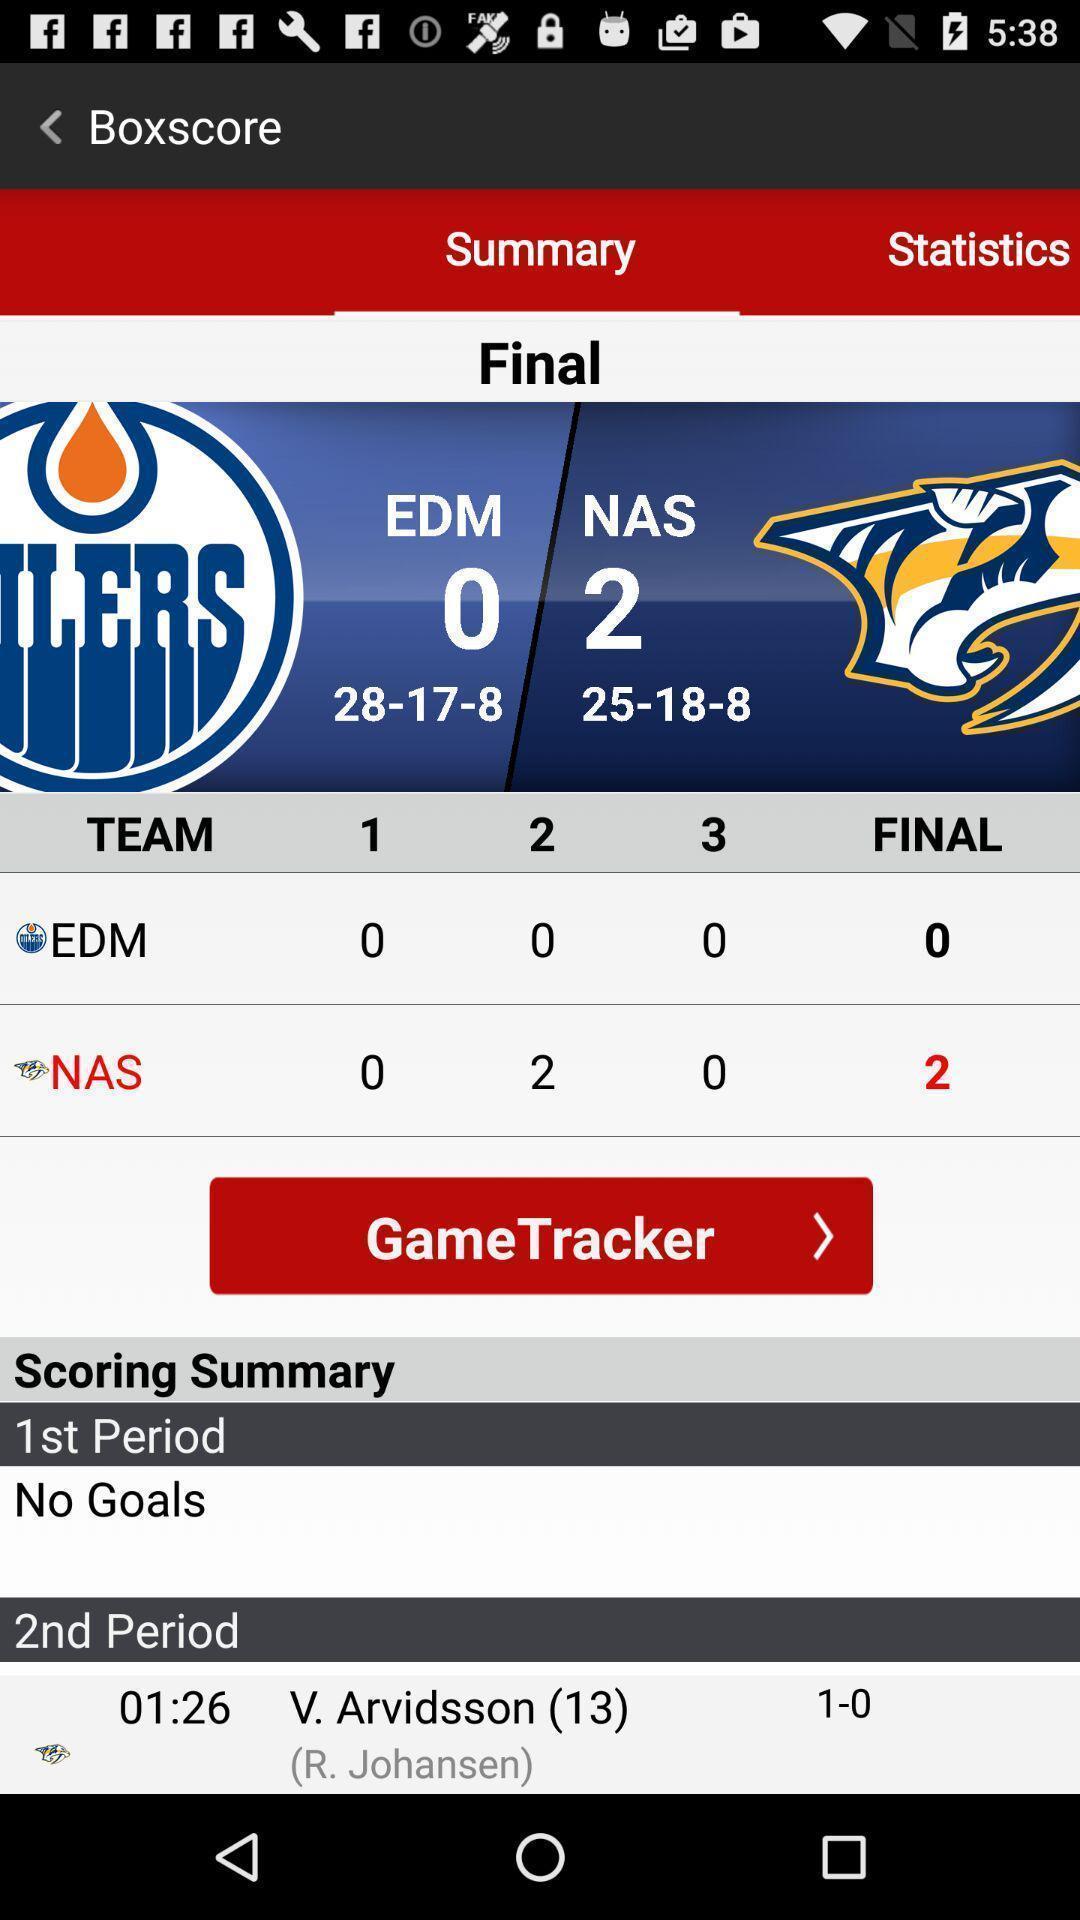Please provide a description for this image. Screen displaying scoreboard information in a gaming application. 